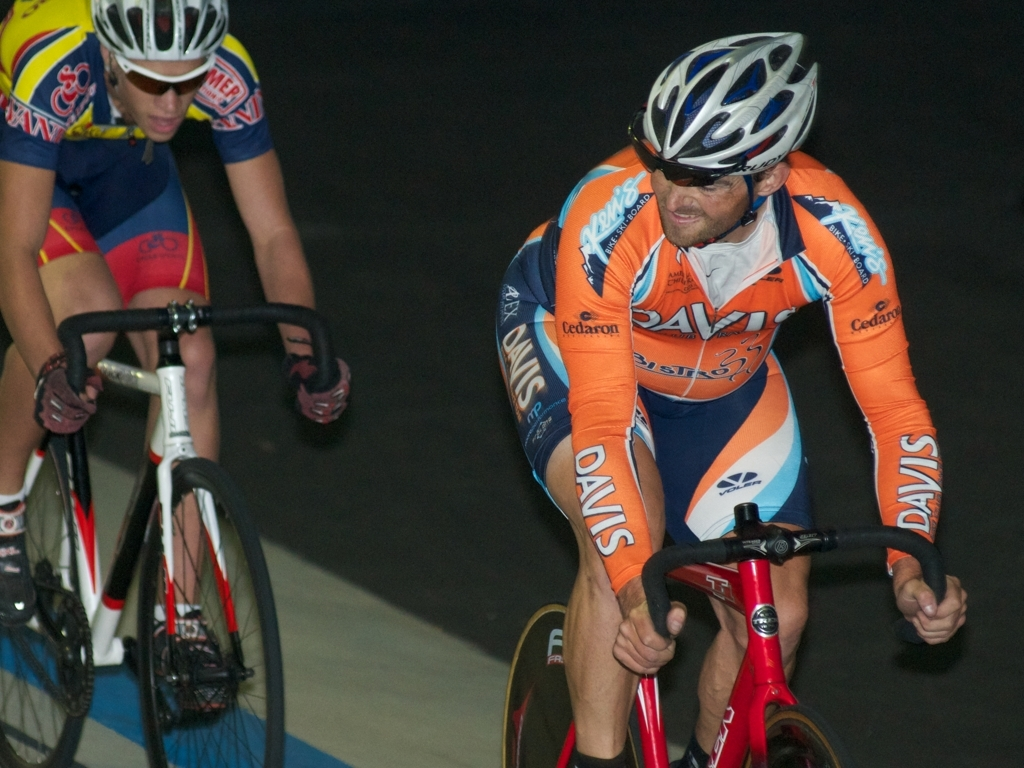How are the colors in this image? The colors in the image are quite vibrant with a dynamic contrast between the bold blues and reds of the cyclists' attire against the subtler tones of the track and background. The athletes' uniforms pop out, making them the focal point of the visual composition, while the darker surroundings help to draw attention to the intensity and motion of the race. 